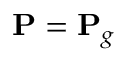Convert formula to latex. <formula><loc_0><loc_0><loc_500><loc_500>{ P } = { P } _ { g }</formula> 